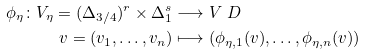<formula> <loc_0><loc_0><loc_500><loc_500>\phi _ { \eta } \colon V _ { \eta } = ( \Delta _ { 3 / 4 } ) ^ { r } \times \Delta _ { 1 } ^ { s } & \longrightarrow V \ D \\ v = ( v _ { 1 } , \dots , v _ { n } ) & \longmapsto ( \phi _ { \eta , 1 } ( v ) , \dots , \phi _ { \eta , n } ( v ) )</formula> 